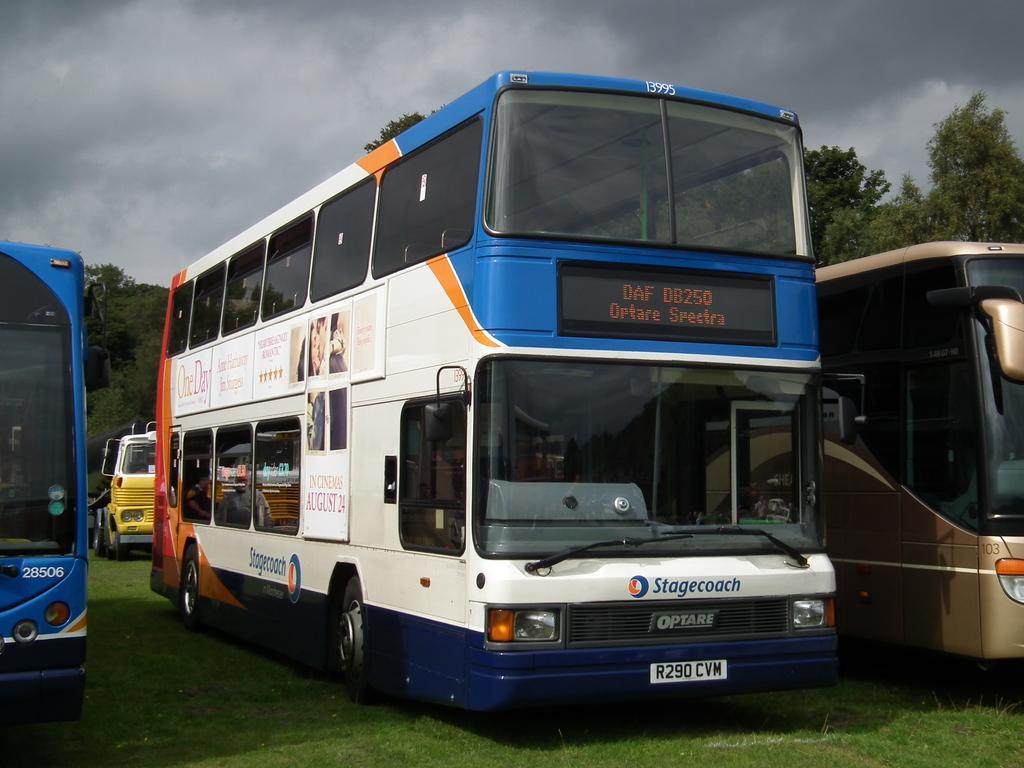Can you describe this image briefly? In this image we can see many vehicles. On the vehicle there are boards. Also there is a screen. On the ground there is grass. In the background there are trees and sky with clouds. 